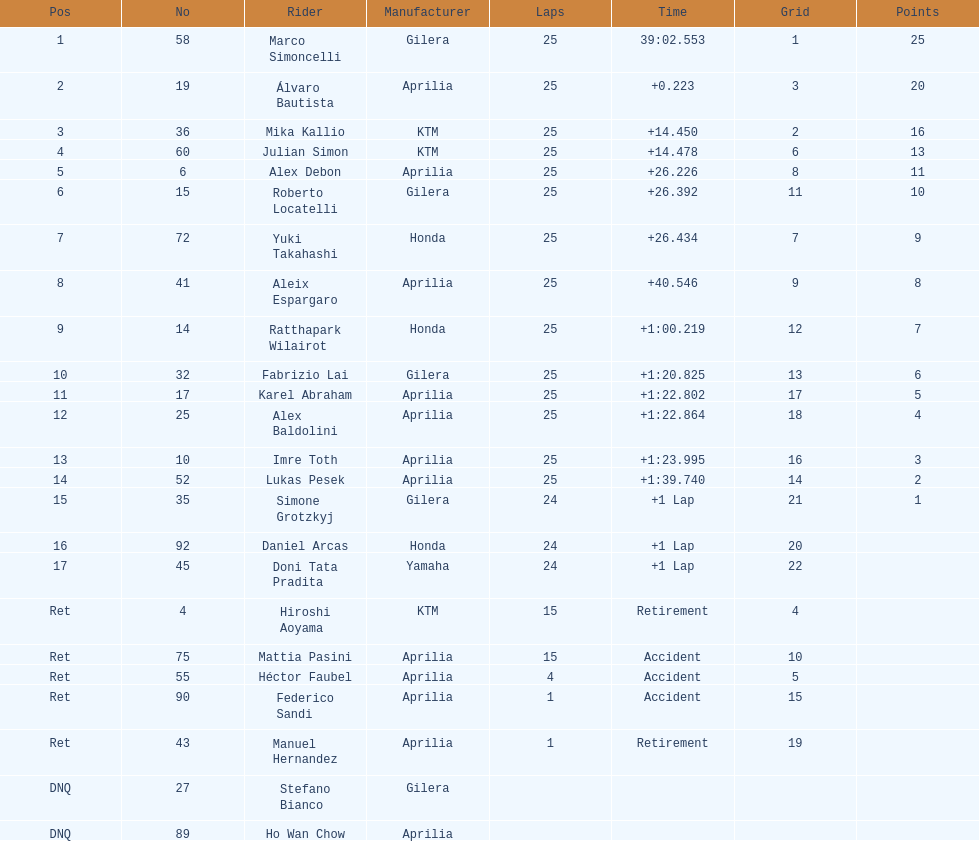What is the total number of laps performed by rider imre toth? 25. 